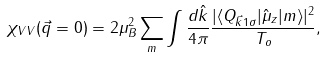Convert formula to latex. <formula><loc_0><loc_0><loc_500><loc_500>\chi _ { V V } ( \vec { q } = 0 ) = 2 \mu ^ { 2 } _ { B } \sum _ { m } \int \frac { d \hat { k } } { 4 \pi } \frac { | \langle Q _ { \vec { k } 1 \sigma } | \hat { \mu } _ { z } | m \rangle | ^ { 2 } } { T _ { o } } ,</formula> 